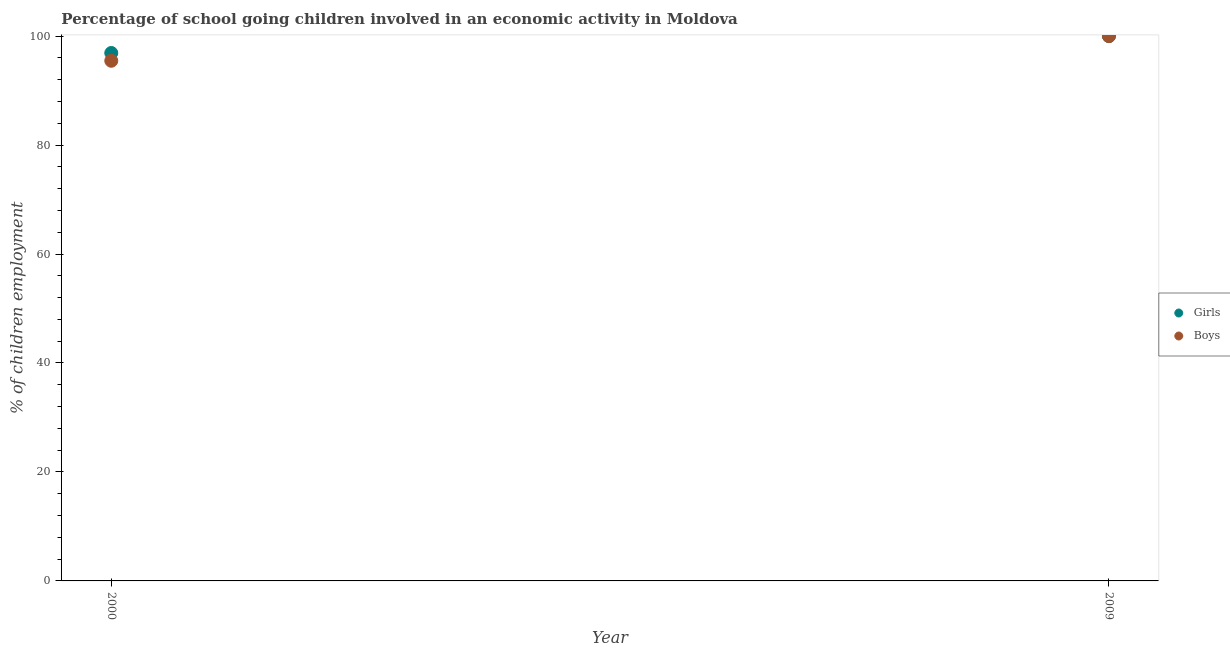How many different coloured dotlines are there?
Give a very brief answer. 2. What is the percentage of school going girls in 2000?
Your answer should be very brief. 96.9. Across all years, what is the minimum percentage of school going boys?
Your response must be concise. 95.47. What is the total percentage of school going girls in the graph?
Offer a very short reply. 196.9. What is the difference between the percentage of school going boys in 2000 and that in 2009?
Give a very brief answer. -4.53. What is the difference between the percentage of school going girls in 2000 and the percentage of school going boys in 2009?
Offer a very short reply. -3.1. What is the average percentage of school going boys per year?
Give a very brief answer. 97.74. What is the ratio of the percentage of school going girls in 2000 to that in 2009?
Keep it short and to the point. 0.97. In how many years, is the percentage of school going boys greater than the average percentage of school going boys taken over all years?
Your response must be concise. 1. Does the percentage of school going boys monotonically increase over the years?
Keep it short and to the point. Yes. Is the percentage of school going girls strictly greater than the percentage of school going boys over the years?
Offer a terse response. No. Is the percentage of school going boys strictly less than the percentage of school going girls over the years?
Provide a short and direct response. No. How many dotlines are there?
Ensure brevity in your answer.  2. How many years are there in the graph?
Your answer should be compact. 2. What is the difference between two consecutive major ticks on the Y-axis?
Ensure brevity in your answer.  20. Are the values on the major ticks of Y-axis written in scientific E-notation?
Your answer should be compact. No. Does the graph contain grids?
Offer a very short reply. No. How many legend labels are there?
Provide a succinct answer. 2. What is the title of the graph?
Keep it short and to the point. Percentage of school going children involved in an economic activity in Moldova. Does "Under-5(male)" appear as one of the legend labels in the graph?
Provide a short and direct response. No. What is the label or title of the Y-axis?
Ensure brevity in your answer.  % of children employment. What is the % of children employment of Girls in 2000?
Your answer should be compact. 96.9. What is the % of children employment of Boys in 2000?
Your response must be concise. 95.47. What is the % of children employment in Girls in 2009?
Provide a succinct answer. 100. Across all years, what is the maximum % of children employment of Boys?
Offer a very short reply. 100. Across all years, what is the minimum % of children employment of Girls?
Your answer should be compact. 96.9. Across all years, what is the minimum % of children employment of Boys?
Ensure brevity in your answer.  95.47. What is the total % of children employment of Girls in the graph?
Keep it short and to the point. 196.9. What is the total % of children employment of Boys in the graph?
Offer a terse response. 195.47. What is the difference between the % of children employment in Girls in 2000 and that in 2009?
Offer a very short reply. -3.1. What is the difference between the % of children employment of Boys in 2000 and that in 2009?
Ensure brevity in your answer.  -4.53. What is the difference between the % of children employment of Girls in 2000 and the % of children employment of Boys in 2009?
Keep it short and to the point. -3.1. What is the average % of children employment in Girls per year?
Your answer should be very brief. 98.45. What is the average % of children employment of Boys per year?
Provide a short and direct response. 97.74. In the year 2000, what is the difference between the % of children employment in Girls and % of children employment in Boys?
Offer a terse response. 1.43. What is the ratio of the % of children employment in Girls in 2000 to that in 2009?
Provide a succinct answer. 0.97. What is the ratio of the % of children employment in Boys in 2000 to that in 2009?
Your answer should be very brief. 0.95. What is the difference between the highest and the second highest % of children employment of Girls?
Offer a terse response. 3.1. What is the difference between the highest and the second highest % of children employment in Boys?
Offer a terse response. 4.53. What is the difference between the highest and the lowest % of children employment of Girls?
Make the answer very short. 3.1. What is the difference between the highest and the lowest % of children employment in Boys?
Your answer should be very brief. 4.53. 